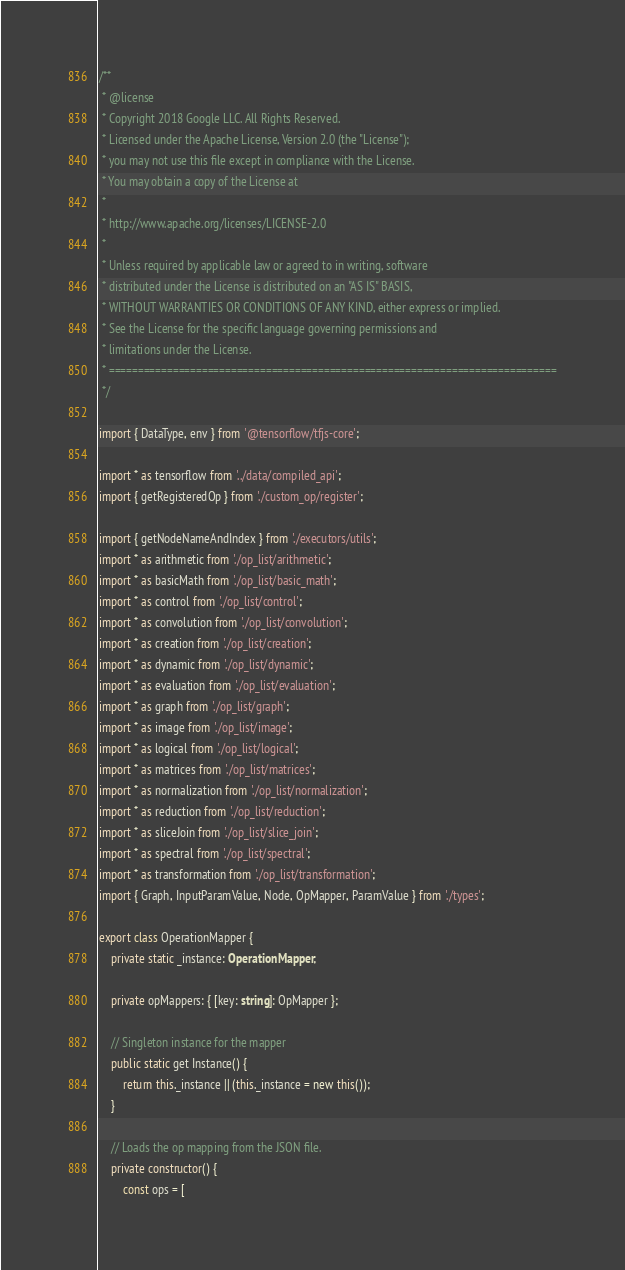<code> <loc_0><loc_0><loc_500><loc_500><_TypeScript_>/**
 * @license
 * Copyright 2018 Google LLC. All Rights Reserved.
 * Licensed under the Apache License, Version 2.0 (the "License");
 * you may not use this file except in compliance with the License.
 * You may obtain a copy of the License at
 *
 * http://www.apache.org/licenses/LICENSE-2.0
 *
 * Unless required by applicable law or agreed to in writing, software
 * distributed under the License is distributed on an "AS IS" BASIS,
 * WITHOUT WARRANTIES OR CONDITIONS OF ANY KIND, either express or implied.
 * See the License for the specific language governing permissions and
 * limitations under the License.
 * =============================================================================
 */

import { DataType, env } from '@tensorflow/tfjs-core';

import * as tensorflow from '../data/compiled_api';
import { getRegisteredOp } from './custom_op/register';

import { getNodeNameAndIndex } from './executors/utils';
import * as arithmetic from './op_list/arithmetic';
import * as basicMath from './op_list/basic_math';
import * as control from './op_list/control';
import * as convolution from './op_list/convolution';
import * as creation from './op_list/creation';
import * as dynamic from './op_list/dynamic';
import * as evaluation from './op_list/evaluation';
import * as graph from './op_list/graph';
import * as image from './op_list/image';
import * as logical from './op_list/logical';
import * as matrices from './op_list/matrices';
import * as normalization from './op_list/normalization';
import * as reduction from './op_list/reduction';
import * as sliceJoin from './op_list/slice_join';
import * as spectral from './op_list/spectral';
import * as transformation from './op_list/transformation';
import { Graph, InputParamValue, Node, OpMapper, ParamValue } from './types';

export class OperationMapper {
    private static _instance: OperationMapper;

    private opMappers: { [key: string]: OpMapper };

    // Singleton instance for the mapper
    public static get Instance() {
        return this._instance || (this._instance = new this());
    }

    // Loads the op mapping from the JSON file.
    private constructor() {
        const ops = [</code> 